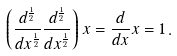<formula> <loc_0><loc_0><loc_500><loc_500>\left ( { \frac { d ^ { \frac { 1 } { 2 } } } { d x ^ { \frac { 1 } { 2 } } } } { \frac { d ^ { \frac { 1 } { 2 } } } { d x ^ { \frac { 1 } { 2 } } } } \right ) x = { \frac { d } { d x } } x = 1 \, .</formula> 